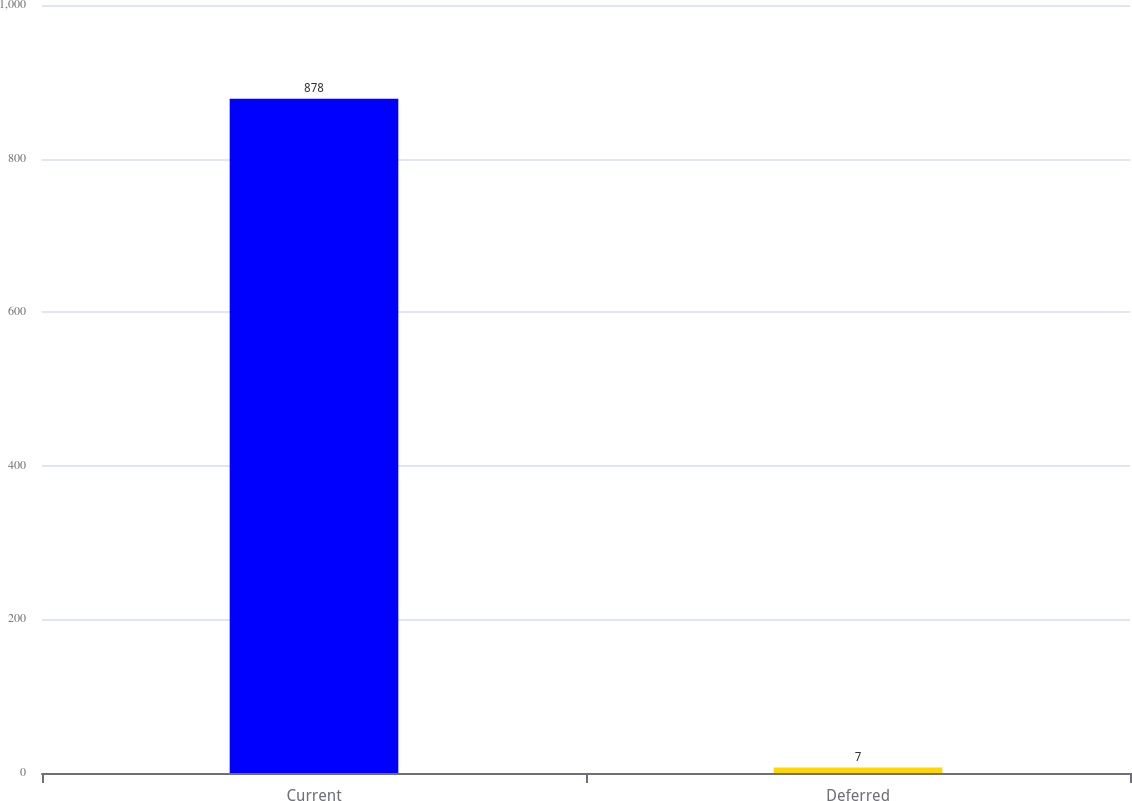Convert chart to OTSL. <chart><loc_0><loc_0><loc_500><loc_500><bar_chart><fcel>Current<fcel>Deferred<nl><fcel>878<fcel>7<nl></chart> 